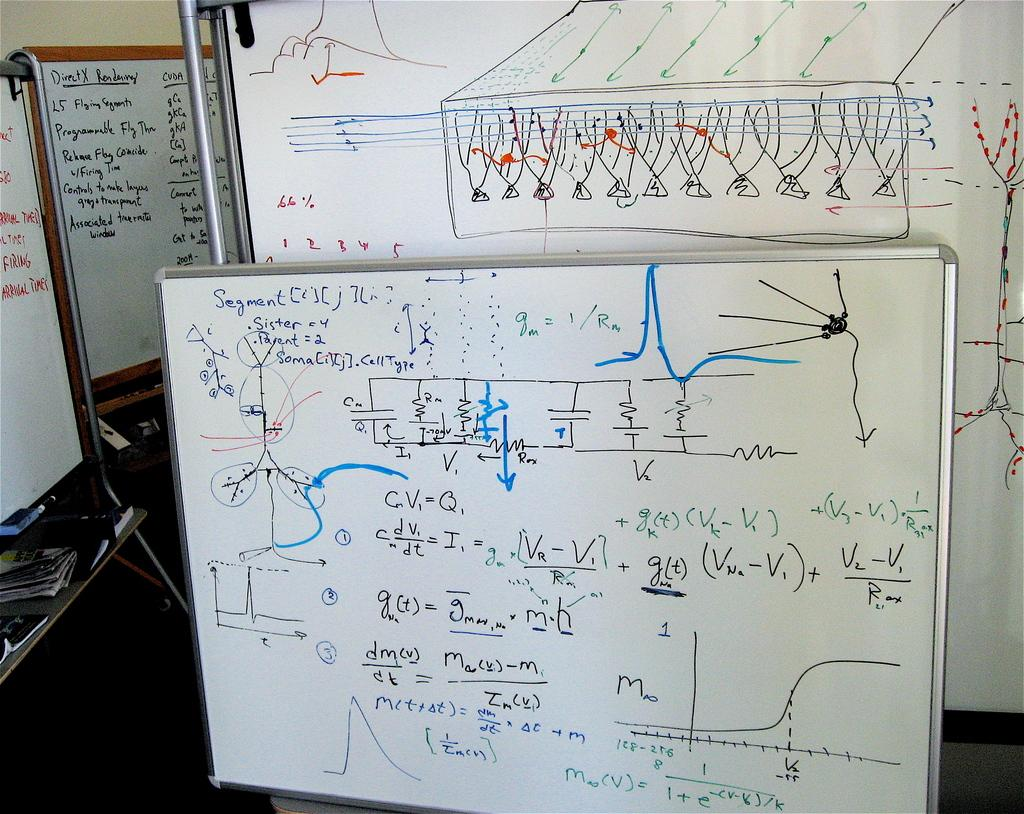<image>
Provide a brief description of the given image. A series of equations and scribbles on a whiteboard starts with the word Segment. 